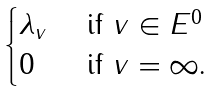Convert formula to latex. <formula><loc_0><loc_0><loc_500><loc_500>\begin{cases} \lambda _ { v } & \text { if $v \in E^{0}$} \\ 0 & \text { if $v = \infty$.} \end{cases}</formula> 